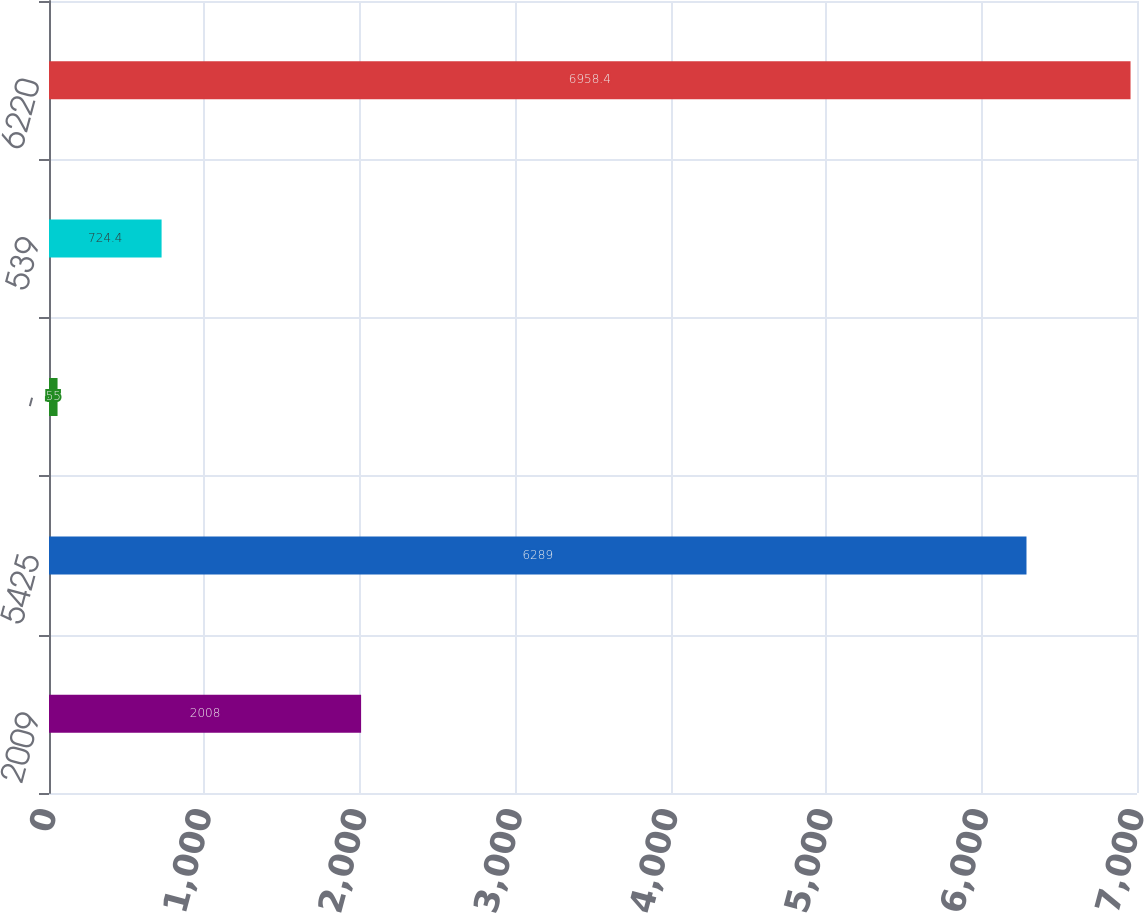Convert chart to OTSL. <chart><loc_0><loc_0><loc_500><loc_500><bar_chart><fcel>2009<fcel>5425<fcel>-<fcel>539<fcel>6220<nl><fcel>2008<fcel>6289<fcel>55<fcel>724.4<fcel>6958.4<nl></chart> 